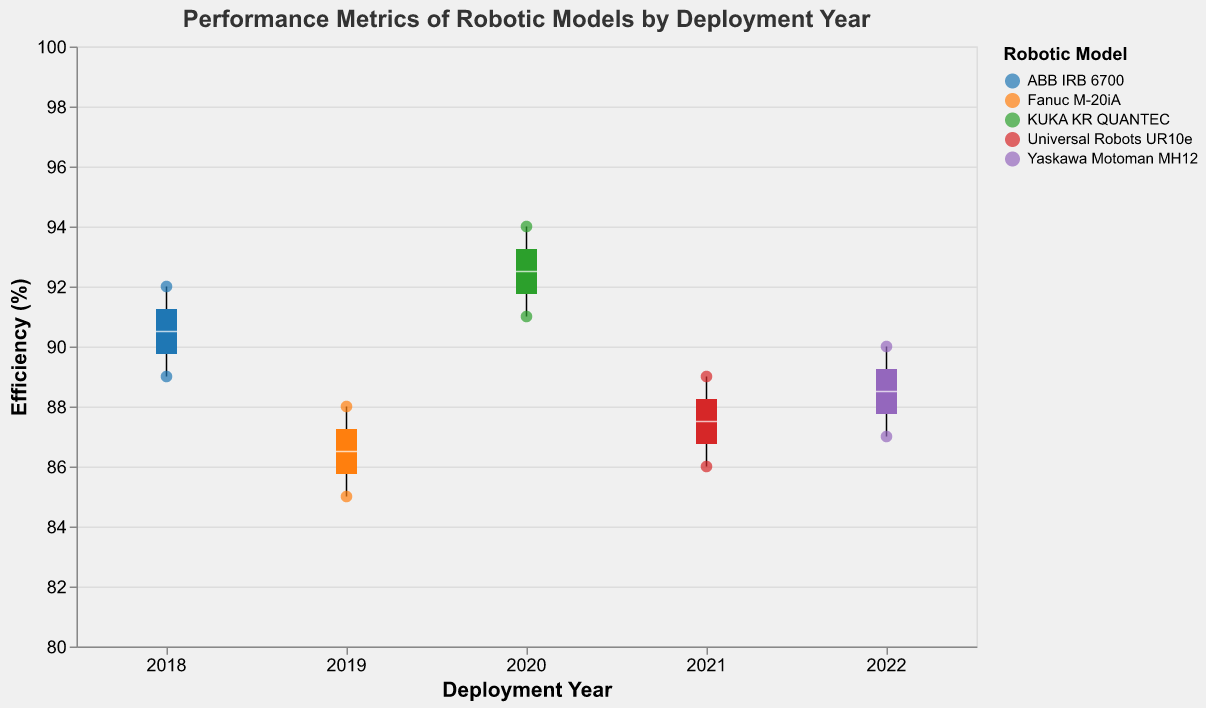What is the title of the figure? The title of the figure is located at the top and is typically descriptive of what the chart represents.
Answer: Performance Metrics of Robotic Models by Deployment Year What is the range of Efficiency (%) shown on the y-axis? The y-axis title and tick marks indicate the range.
Answer: 80 to 100 Which robotic model shows the highest efficiency in 2020? By looking at the scatter points and identifying the highest y-value for the year 2020, we see which model has the highest efficiency.
Answer: KUKA KR QUANTEC What deployment year has the highest median Efficiency (%)? The median of each year's boxplot (indicated by a bold or white line) shows the median Efficiency (%).
Answer: 2020 Which robotic model had the widest range of Efficiency (%) in 2019? The range of Efficiency (%) for each model is the distance between the minimum and maximum points of the error bars in the boxplot.
Answer: Fanuc M-20iA Compare the median Downtime (hours/month) of ABB IRB 6700 in 2018 with KUKA KR QUANTEC in 2020. Which is lower? By examining the points situated at the median vertical line for both models within their respective years.
Answer: KUKA KR QUANTEC in 2020 Which colors represent ABB IRB 6700 and Universal Robots UR10e respectively? By looking at the legend, we can identify which color corresponds to each model.
Answer: ABB IRB 6700: blue, Universal Robots UR10e: red Is there any year where the box plots for Efficiency (%) do not overlap for any robotic models? By visually examining if the range bars of the box plots overlap for all years.
Answer: No Which robotic model had the least variation in Efficiency (%) in 2022? The least variation is seen in the box plot with the smallest interquartile range (IQR).
Answer: Yaskawa Motoman MH12 What is the difference in median Efficiency (%) between the highest and lowest performing models in 2021? Determine the median value from the boxplot's median line for each model and subtract the lowest from the highest.
Answer: 3 